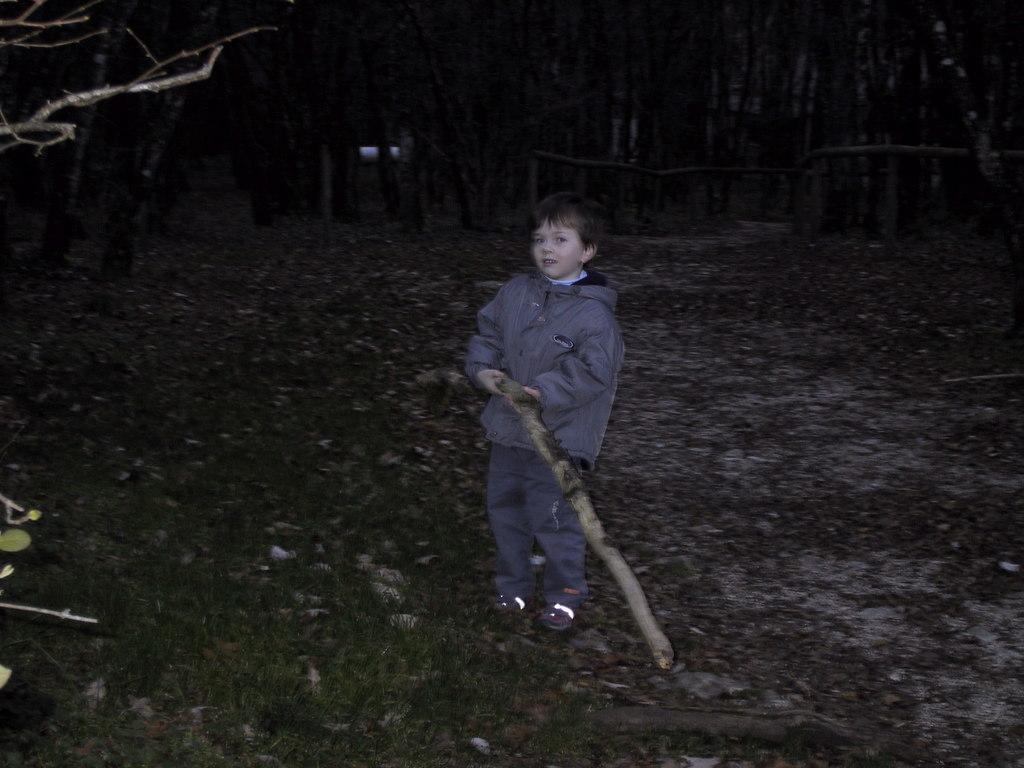In one or two sentences, can you explain what this image depicts? In this picture I can see a boy standing and holding a wooden staff, there is grass, and in the background there are trees. 